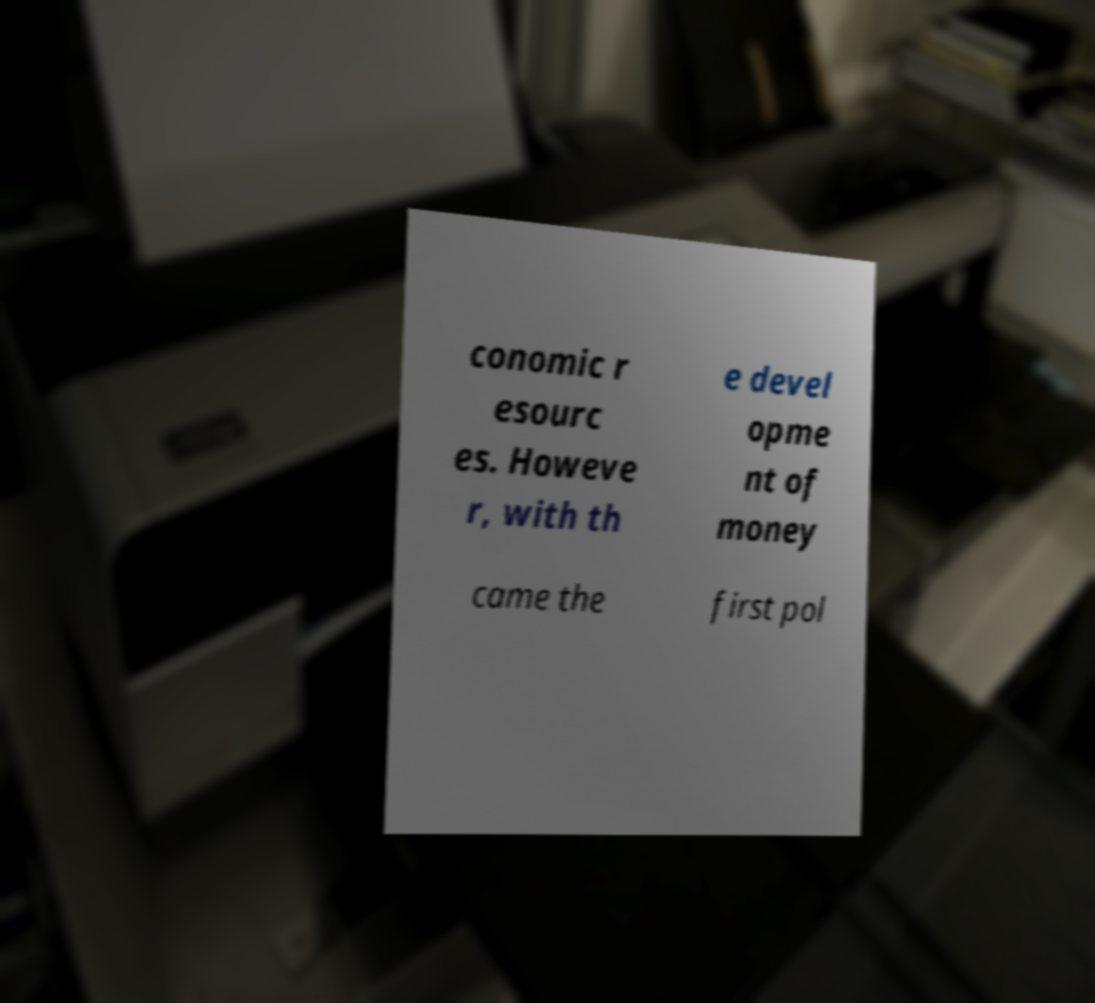Could you extract and type out the text from this image? conomic r esourc es. Howeve r, with th e devel opme nt of money came the first pol 